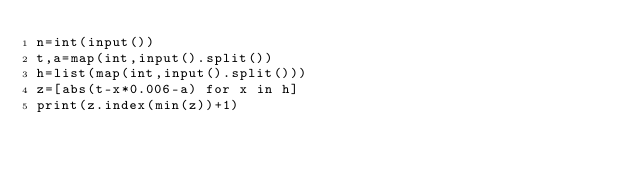Convert code to text. <code><loc_0><loc_0><loc_500><loc_500><_Python_>n=int(input())
t,a=map(int,input().split())
h=list(map(int,input().split()))
z=[abs(t-x*0.006-a) for x in h]
print(z.index(min(z))+1)</code> 